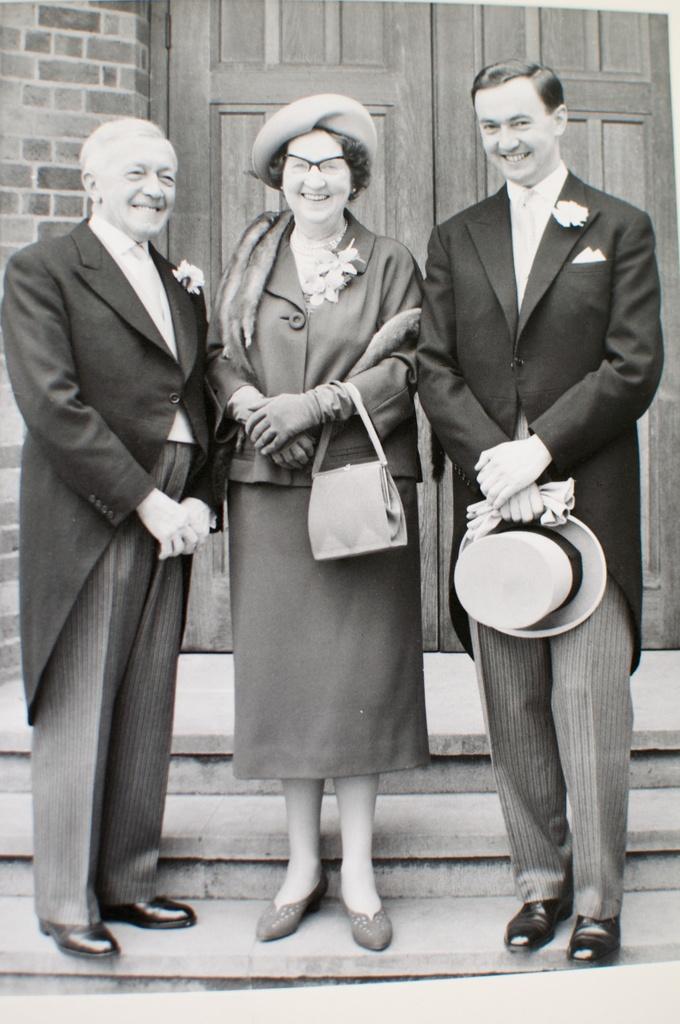Describe this image in one or two sentences. there are two people standing and laughing in which two are men and one is woman. 